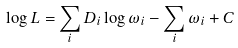Convert formula to latex. <formula><loc_0><loc_0><loc_500><loc_500>\log { L } = \sum _ { i } D _ { i } \log { \omega _ { i } } - \sum _ { i } \omega _ { i } + C</formula> 